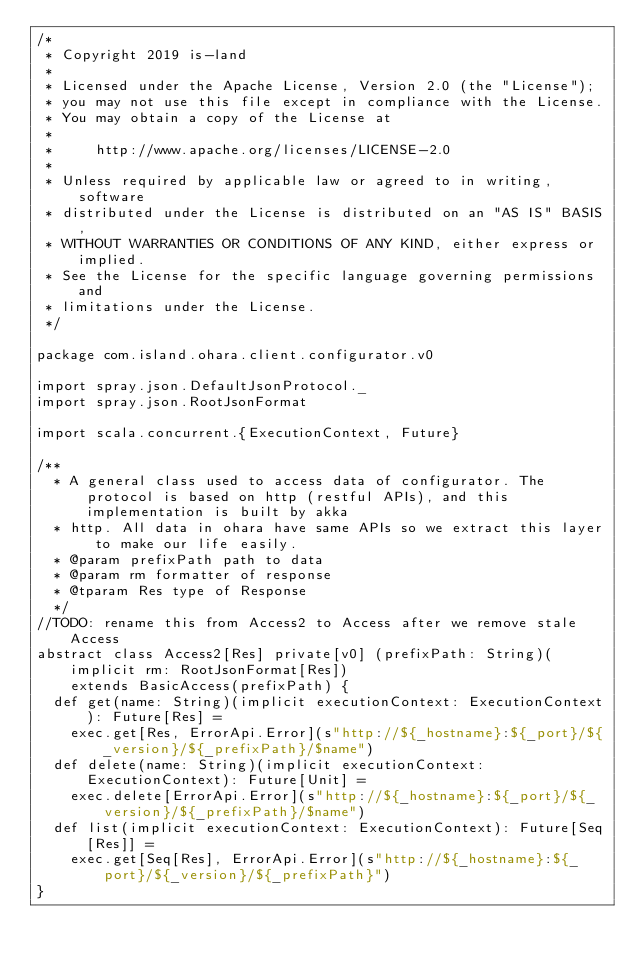Convert code to text. <code><loc_0><loc_0><loc_500><loc_500><_Scala_>/*
 * Copyright 2019 is-land
 *
 * Licensed under the Apache License, Version 2.0 (the "License");
 * you may not use this file except in compliance with the License.
 * You may obtain a copy of the License at
 *
 *     http://www.apache.org/licenses/LICENSE-2.0
 *
 * Unless required by applicable law or agreed to in writing, software
 * distributed under the License is distributed on an "AS IS" BASIS,
 * WITHOUT WARRANTIES OR CONDITIONS OF ANY KIND, either express or implied.
 * See the License for the specific language governing permissions and
 * limitations under the License.
 */

package com.island.ohara.client.configurator.v0

import spray.json.DefaultJsonProtocol._
import spray.json.RootJsonFormat

import scala.concurrent.{ExecutionContext, Future}

/**
  * A general class used to access data of configurator. The protocol is based on http (restful APIs), and this implementation is built by akka
  * http. All data in ohara have same APIs so we extract this layer to make our life easily.
  * @param prefixPath path to data
  * @param rm formatter of response
  * @tparam Res type of Response
  */
//TODO: rename this from Access2 to Access after we remove stale Access
abstract class Access2[Res] private[v0] (prefixPath: String)(implicit rm: RootJsonFormat[Res])
    extends BasicAccess(prefixPath) {
  def get(name: String)(implicit executionContext: ExecutionContext): Future[Res] =
    exec.get[Res, ErrorApi.Error](s"http://${_hostname}:${_port}/${_version}/${_prefixPath}/$name")
  def delete(name: String)(implicit executionContext: ExecutionContext): Future[Unit] =
    exec.delete[ErrorApi.Error](s"http://${_hostname}:${_port}/${_version}/${_prefixPath}/$name")
  def list(implicit executionContext: ExecutionContext): Future[Seq[Res]] =
    exec.get[Seq[Res], ErrorApi.Error](s"http://${_hostname}:${_port}/${_version}/${_prefixPath}")
}
</code> 